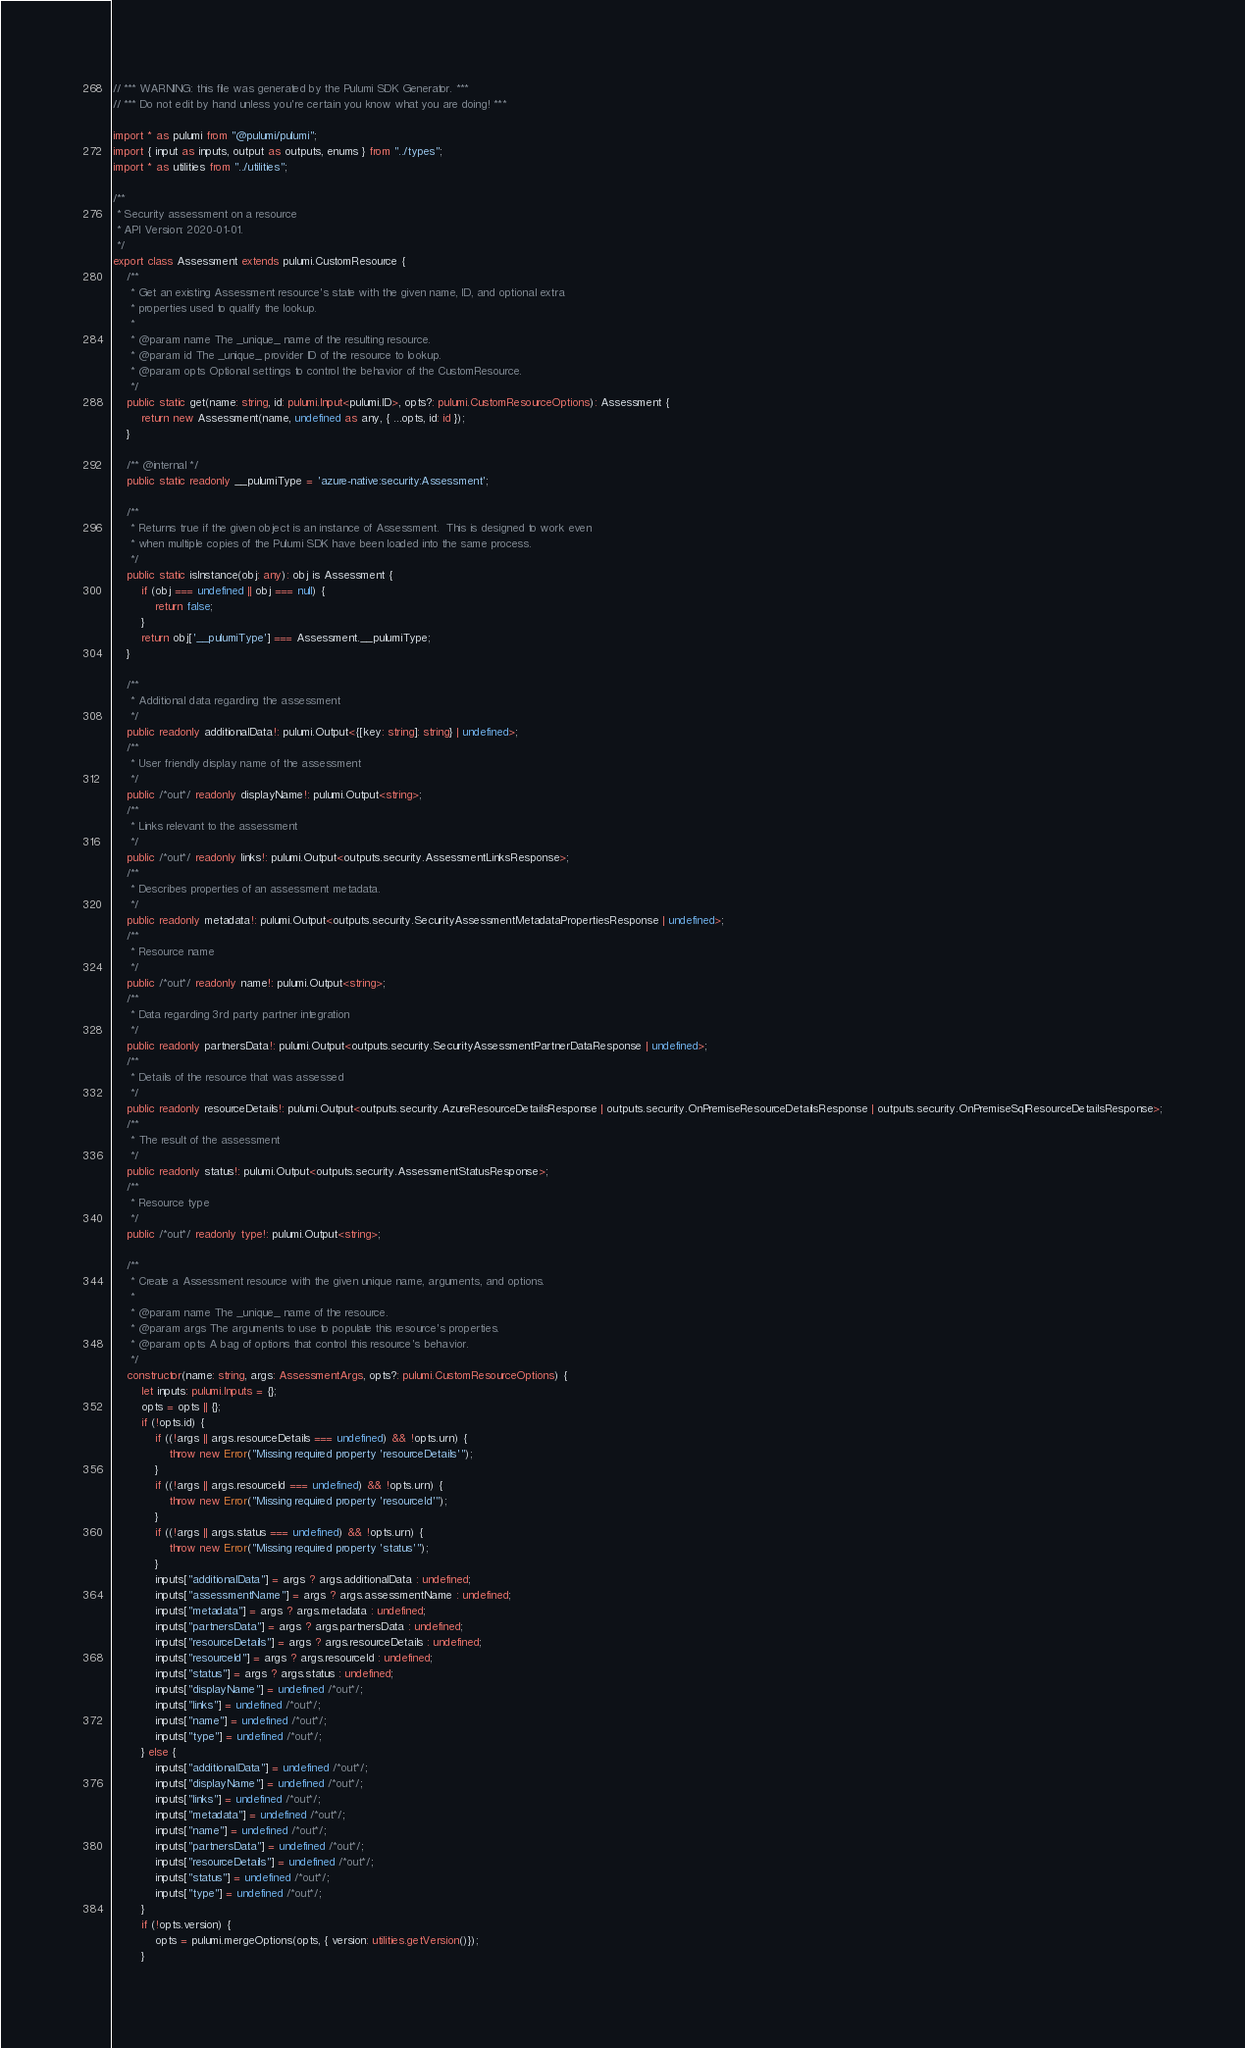Convert code to text. <code><loc_0><loc_0><loc_500><loc_500><_TypeScript_>// *** WARNING: this file was generated by the Pulumi SDK Generator. ***
// *** Do not edit by hand unless you're certain you know what you are doing! ***

import * as pulumi from "@pulumi/pulumi";
import { input as inputs, output as outputs, enums } from "../types";
import * as utilities from "../utilities";

/**
 * Security assessment on a resource
 * API Version: 2020-01-01.
 */
export class Assessment extends pulumi.CustomResource {
    /**
     * Get an existing Assessment resource's state with the given name, ID, and optional extra
     * properties used to qualify the lookup.
     *
     * @param name The _unique_ name of the resulting resource.
     * @param id The _unique_ provider ID of the resource to lookup.
     * @param opts Optional settings to control the behavior of the CustomResource.
     */
    public static get(name: string, id: pulumi.Input<pulumi.ID>, opts?: pulumi.CustomResourceOptions): Assessment {
        return new Assessment(name, undefined as any, { ...opts, id: id });
    }

    /** @internal */
    public static readonly __pulumiType = 'azure-native:security:Assessment';

    /**
     * Returns true if the given object is an instance of Assessment.  This is designed to work even
     * when multiple copies of the Pulumi SDK have been loaded into the same process.
     */
    public static isInstance(obj: any): obj is Assessment {
        if (obj === undefined || obj === null) {
            return false;
        }
        return obj['__pulumiType'] === Assessment.__pulumiType;
    }

    /**
     * Additional data regarding the assessment
     */
    public readonly additionalData!: pulumi.Output<{[key: string]: string} | undefined>;
    /**
     * User friendly display name of the assessment
     */
    public /*out*/ readonly displayName!: pulumi.Output<string>;
    /**
     * Links relevant to the assessment
     */
    public /*out*/ readonly links!: pulumi.Output<outputs.security.AssessmentLinksResponse>;
    /**
     * Describes properties of an assessment metadata.
     */
    public readonly metadata!: pulumi.Output<outputs.security.SecurityAssessmentMetadataPropertiesResponse | undefined>;
    /**
     * Resource name
     */
    public /*out*/ readonly name!: pulumi.Output<string>;
    /**
     * Data regarding 3rd party partner integration
     */
    public readonly partnersData!: pulumi.Output<outputs.security.SecurityAssessmentPartnerDataResponse | undefined>;
    /**
     * Details of the resource that was assessed
     */
    public readonly resourceDetails!: pulumi.Output<outputs.security.AzureResourceDetailsResponse | outputs.security.OnPremiseResourceDetailsResponse | outputs.security.OnPremiseSqlResourceDetailsResponse>;
    /**
     * The result of the assessment
     */
    public readonly status!: pulumi.Output<outputs.security.AssessmentStatusResponse>;
    /**
     * Resource type
     */
    public /*out*/ readonly type!: pulumi.Output<string>;

    /**
     * Create a Assessment resource with the given unique name, arguments, and options.
     *
     * @param name The _unique_ name of the resource.
     * @param args The arguments to use to populate this resource's properties.
     * @param opts A bag of options that control this resource's behavior.
     */
    constructor(name: string, args: AssessmentArgs, opts?: pulumi.CustomResourceOptions) {
        let inputs: pulumi.Inputs = {};
        opts = opts || {};
        if (!opts.id) {
            if ((!args || args.resourceDetails === undefined) && !opts.urn) {
                throw new Error("Missing required property 'resourceDetails'");
            }
            if ((!args || args.resourceId === undefined) && !opts.urn) {
                throw new Error("Missing required property 'resourceId'");
            }
            if ((!args || args.status === undefined) && !opts.urn) {
                throw new Error("Missing required property 'status'");
            }
            inputs["additionalData"] = args ? args.additionalData : undefined;
            inputs["assessmentName"] = args ? args.assessmentName : undefined;
            inputs["metadata"] = args ? args.metadata : undefined;
            inputs["partnersData"] = args ? args.partnersData : undefined;
            inputs["resourceDetails"] = args ? args.resourceDetails : undefined;
            inputs["resourceId"] = args ? args.resourceId : undefined;
            inputs["status"] = args ? args.status : undefined;
            inputs["displayName"] = undefined /*out*/;
            inputs["links"] = undefined /*out*/;
            inputs["name"] = undefined /*out*/;
            inputs["type"] = undefined /*out*/;
        } else {
            inputs["additionalData"] = undefined /*out*/;
            inputs["displayName"] = undefined /*out*/;
            inputs["links"] = undefined /*out*/;
            inputs["metadata"] = undefined /*out*/;
            inputs["name"] = undefined /*out*/;
            inputs["partnersData"] = undefined /*out*/;
            inputs["resourceDetails"] = undefined /*out*/;
            inputs["status"] = undefined /*out*/;
            inputs["type"] = undefined /*out*/;
        }
        if (!opts.version) {
            opts = pulumi.mergeOptions(opts, { version: utilities.getVersion()});
        }</code> 